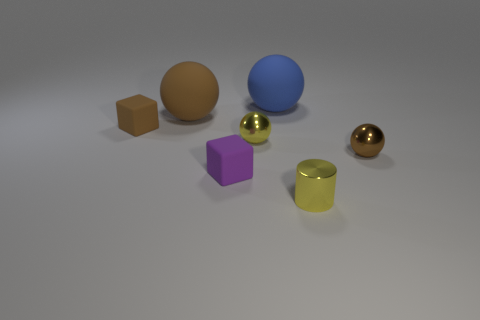There is a tiny metallic thing that is the same color as the small cylinder; what shape is it?
Your answer should be compact. Sphere. Are any tiny gray cylinders visible?
Your response must be concise. No. Do the purple thing and the sphere that is to the left of the yellow metal sphere have the same size?
Give a very brief answer. No. There is a tiny metal thing that is in front of the brown metal object; are there any big brown balls that are in front of it?
Ensure brevity in your answer.  No. There is a brown object that is left of the yellow cylinder and in front of the large brown thing; what is its material?
Your answer should be compact. Rubber. The big object on the left side of the yellow metallic ball that is to the right of the brown ball to the left of the small yellow ball is what color?
Your response must be concise. Brown. What is the color of the other object that is the same size as the blue object?
Offer a very short reply. Brown. Do the cylinder and the ball behind the big brown thing have the same color?
Ensure brevity in your answer.  No. What material is the tiny brown object that is to the right of the yellow metal object to the left of the tiny cylinder made of?
Your answer should be very brief. Metal. What number of small spheres are to the left of the large blue sphere and on the right side of the blue sphere?
Ensure brevity in your answer.  0. 